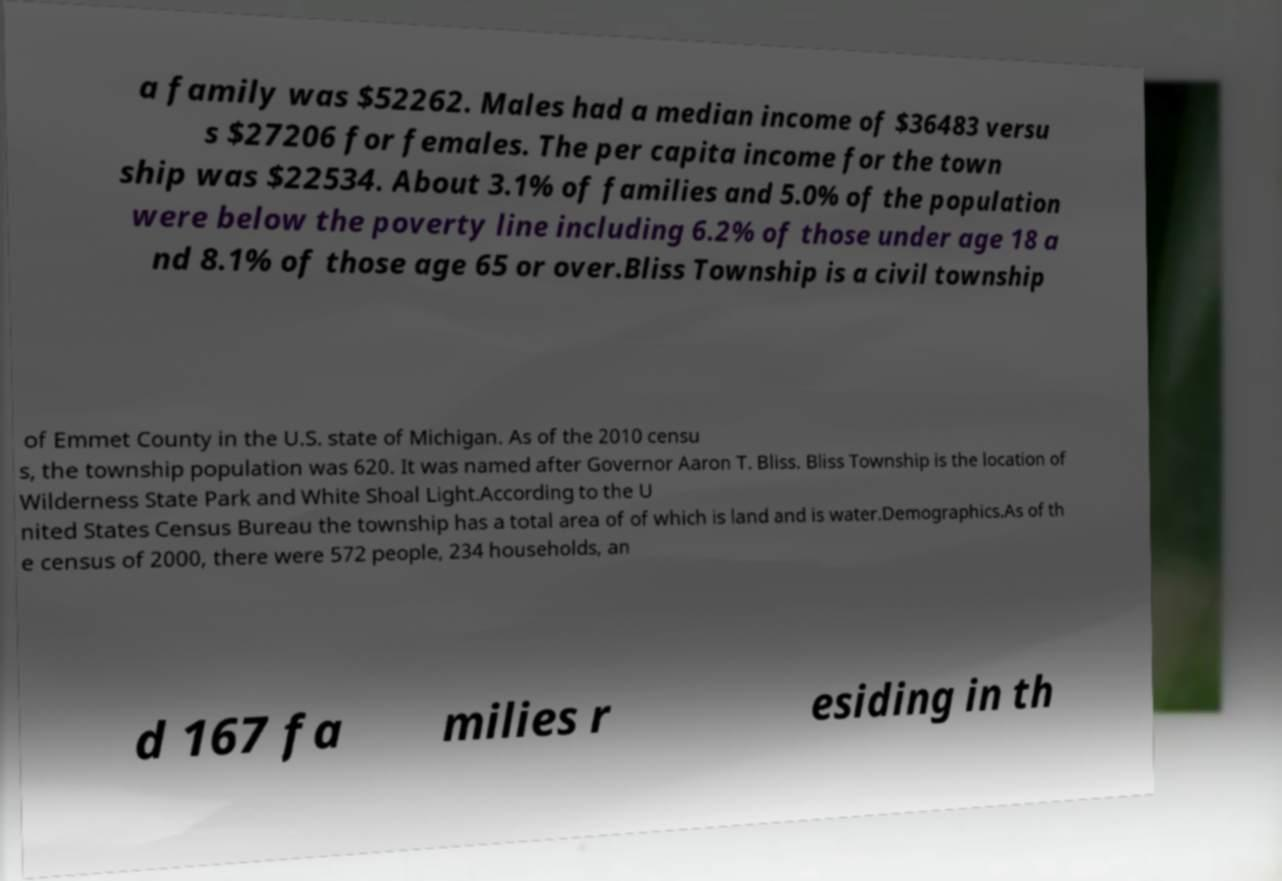Please identify and transcribe the text found in this image. a family was $52262. Males had a median income of $36483 versu s $27206 for females. The per capita income for the town ship was $22534. About 3.1% of families and 5.0% of the population were below the poverty line including 6.2% of those under age 18 a nd 8.1% of those age 65 or over.Bliss Township is a civil township of Emmet County in the U.S. state of Michigan. As of the 2010 censu s, the township population was 620. It was named after Governor Aaron T. Bliss. Bliss Township is the location of Wilderness State Park and White Shoal Light.According to the U nited States Census Bureau the township has a total area of of which is land and is water.Demographics.As of th e census of 2000, there were 572 people, 234 households, an d 167 fa milies r esiding in th 